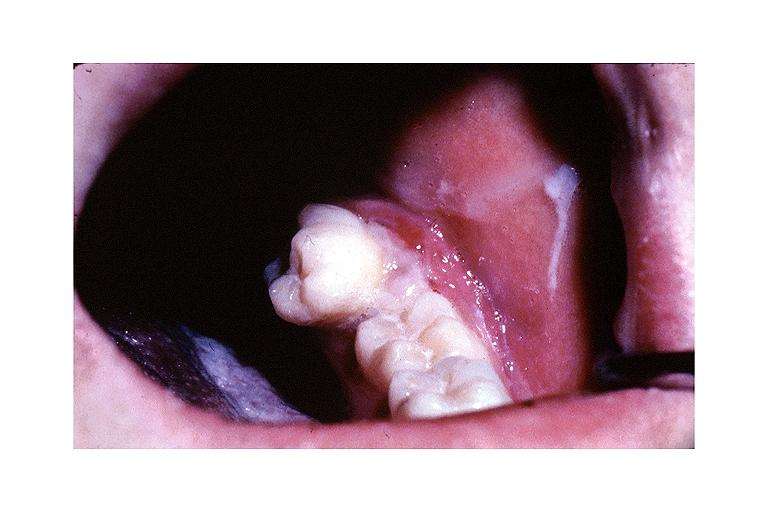s ulcer present?
Answer the question using a single word or phrase. No 